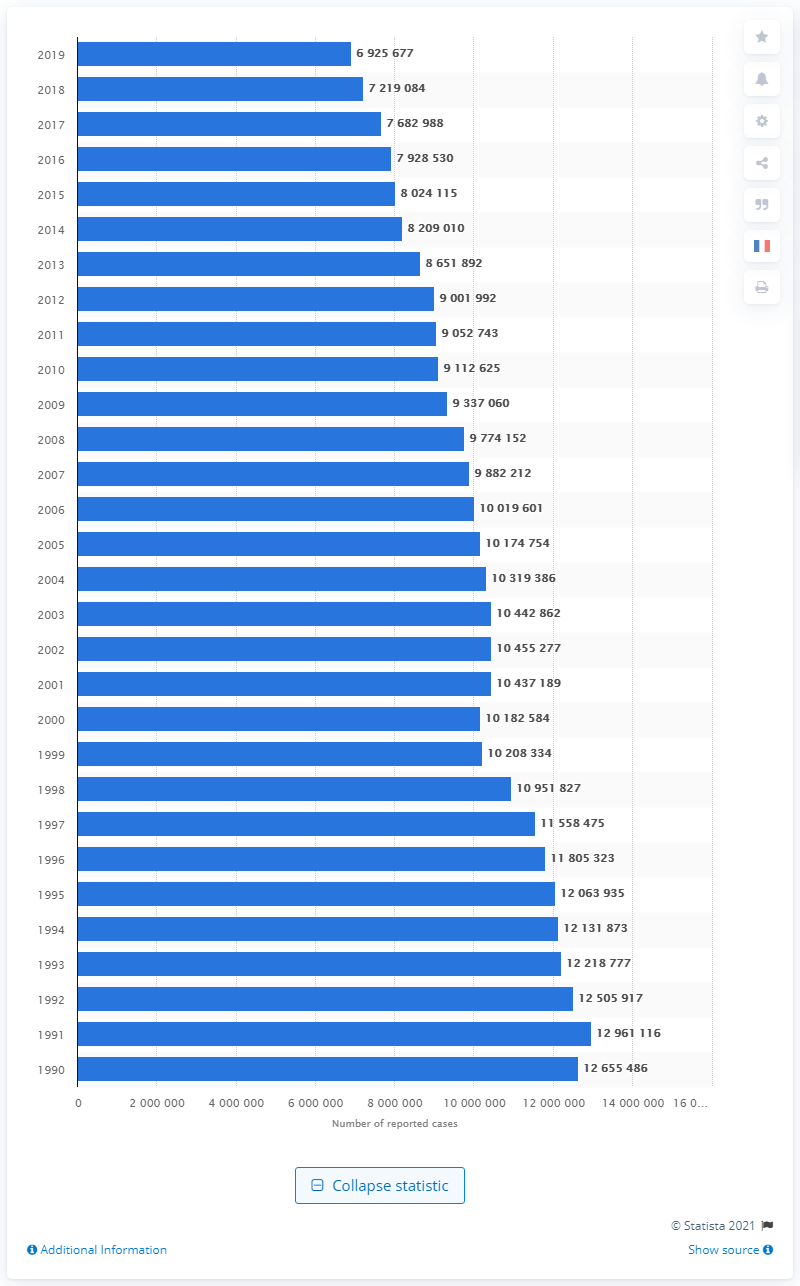Specify some key components in this picture. In 2019, there were 692,567 reported property crime cases in the United States. 